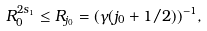<formula> <loc_0><loc_0><loc_500><loc_500>R _ { 0 } ^ { 2 s _ { 1 } } \leq R _ { j _ { 0 } } = ( \gamma ( j _ { 0 } + 1 / 2 ) ) ^ { - 1 } ,</formula> 